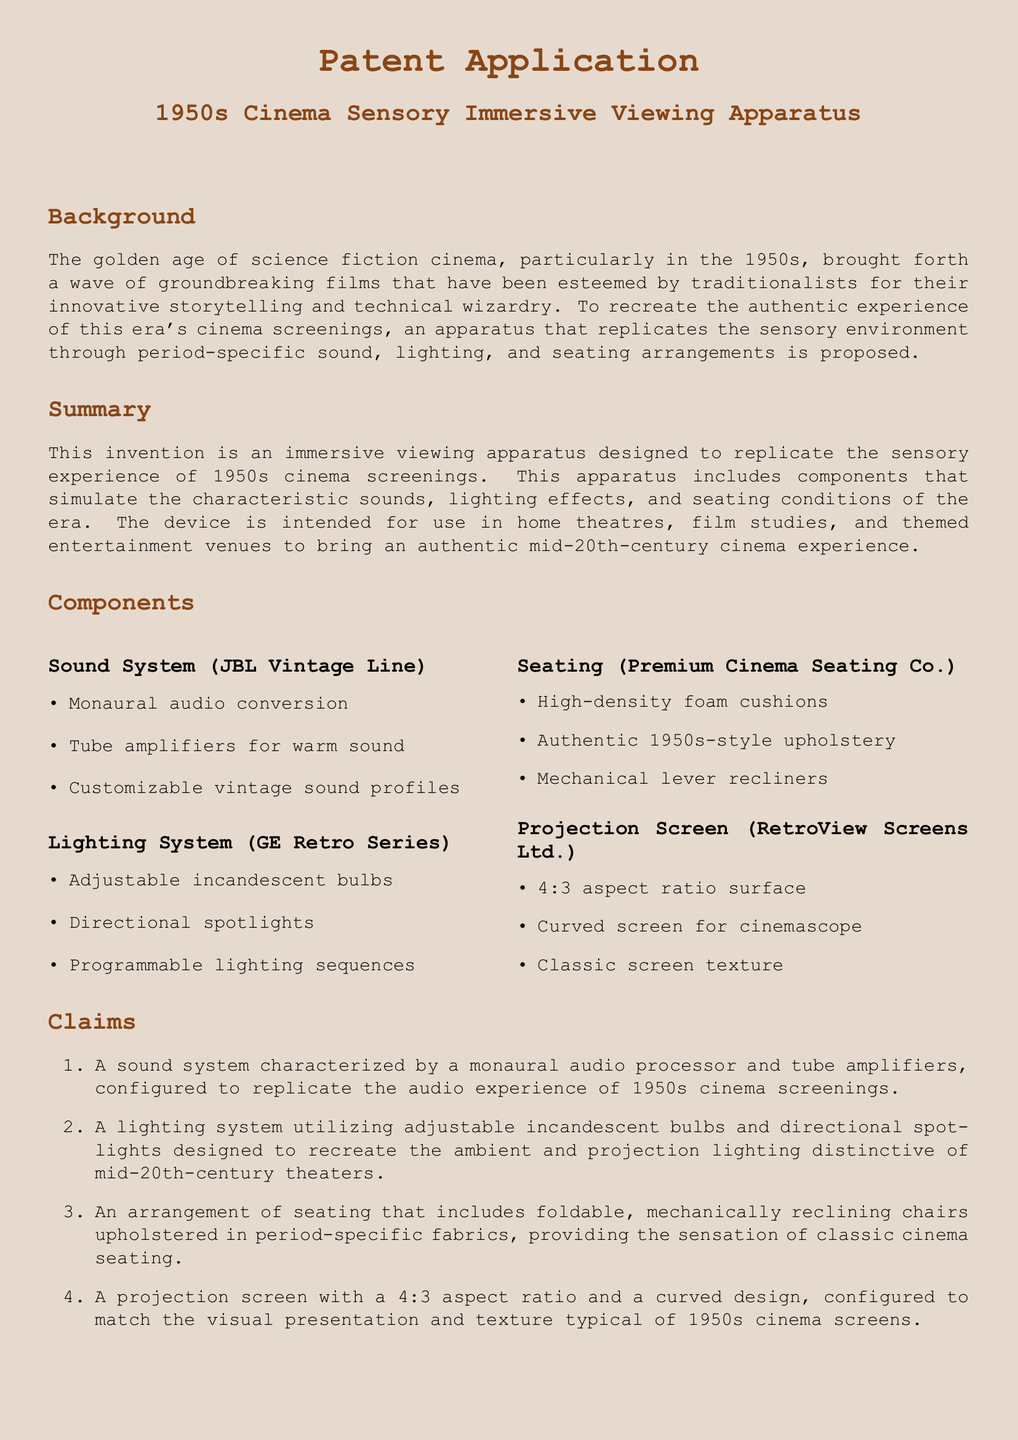what is the title of the patent? The title of the patent is found at the beginning of the document, identifying the invention.
Answer: 1950s Cinema Sensory Immersive Viewing Apparatus what sound system is mentioned in the document? The sound system is specified in the components section indicating its name and characteristics.
Answer: JBL Vintage Line how many claims does the patent application have? The total number of claims is listed in the claims section of the document.
Answer: Four what is the aspect ratio of the projection screen? The aspect ratio is explicitly stated in the projection screen component.
Answer: 4:3 what type of bulbs are used in the lighting system? The type of bulbs is mentioned in the description of the lighting system.
Answer: Incandescent how does the seating arrangement enhance the experience? This question requires reasoning about the seating design and its historical authenticity.
Answer: Provides classic cinema seating sensation what is the purpose of the immersive viewing apparatus? The purpose is detailed in the summary section, clarifying its intended use.
Answer: To replicate the sensory experience of 1950s cinema screenings which company produces the seating mentioned in the document? The company responsible for the seating is noted in the corresponding component section.
Answer: Premium Cinema Seating Co 